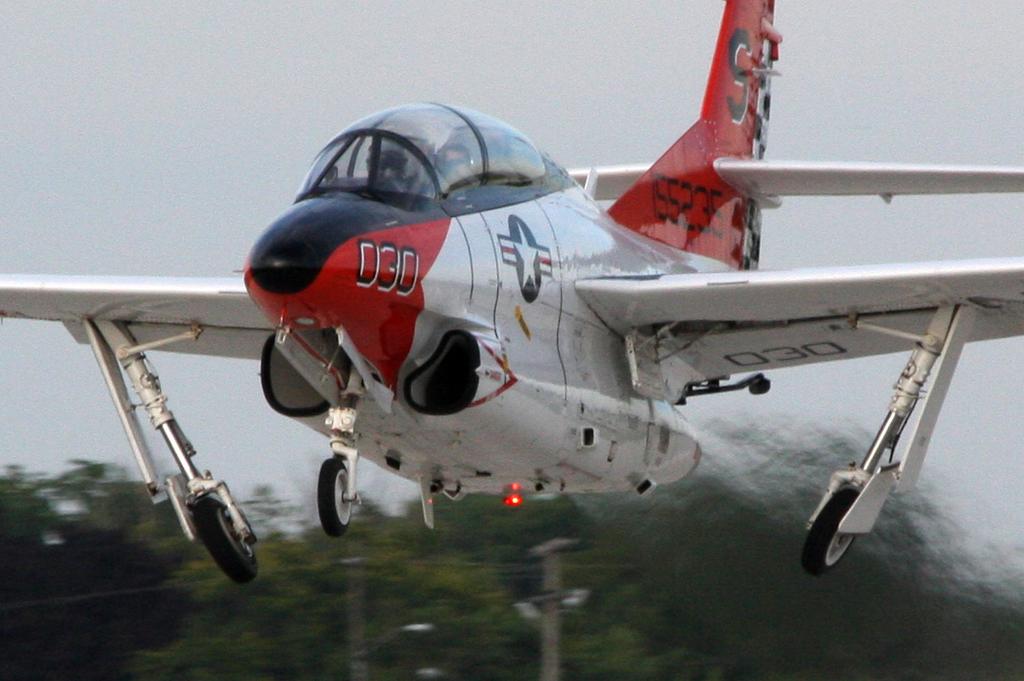What number and  letter is shown at the top of the plane?
Provide a short and direct response. 030 s. What number is on the nose of the plane?
Offer a terse response. 030. 